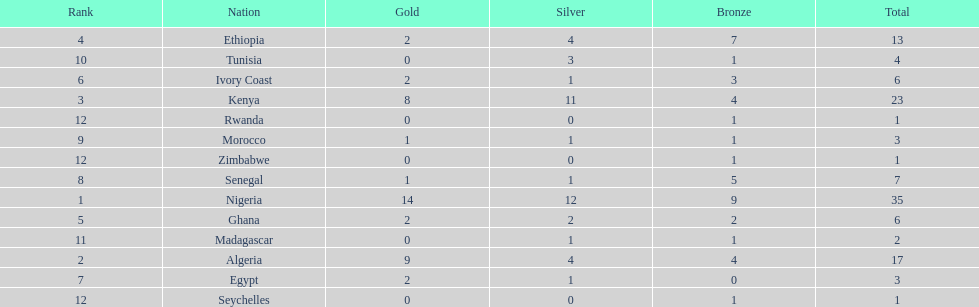Parse the full table. {'header': ['Rank', 'Nation', 'Gold', 'Silver', 'Bronze', 'Total'], 'rows': [['4', 'Ethiopia', '2', '4', '7', '13'], ['10', 'Tunisia', '0', '3', '1', '4'], ['6', 'Ivory Coast', '2', '1', '3', '6'], ['3', 'Kenya', '8', '11', '4', '23'], ['12', 'Rwanda', '0', '0', '1', '1'], ['9', 'Morocco', '1', '1', '1', '3'], ['12', 'Zimbabwe', '0', '0', '1', '1'], ['8', 'Senegal', '1', '1', '5', '7'], ['1', 'Nigeria', '14', '12', '9', '35'], ['5', 'Ghana', '2', '2', '2', '6'], ['11', 'Madagascar', '0', '1', '1', '2'], ['2', 'Algeria', '9', '4', '4', '17'], ['7', 'Egypt', '2', '1', '0', '3'], ['12', 'Seychelles', '0', '0', '1', '1']]} The team before algeria Nigeria. 